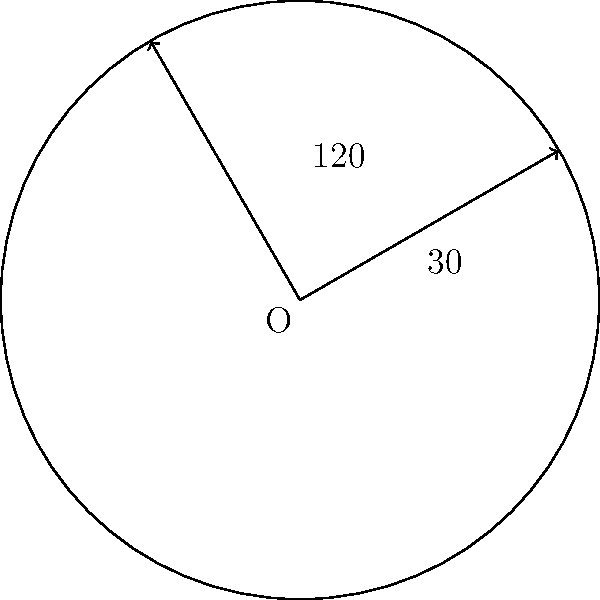As a marine surveyor, you're analyzing a circular radar display. The display shows two vessels at bearings of 30° and 120° from your ship. What is the central angle of the sector between these two vessels? To find the central angle of the sector between the two vessels, we need to follow these steps:

1. Identify the given bearings:
   - Vessel 1 is at 30°
   - Vessel 2 is at 120°

2. Calculate the difference between the two bearings:
   $120° - 30° = 90°$

3. The central angle of a sector is the angle formed at the center of the circle between two radii.

4. In this case, the central angle is equal to the difference between the two bearings.

Therefore, the central angle of the sector between the two vessels is 90°.
Answer: $90°$ 